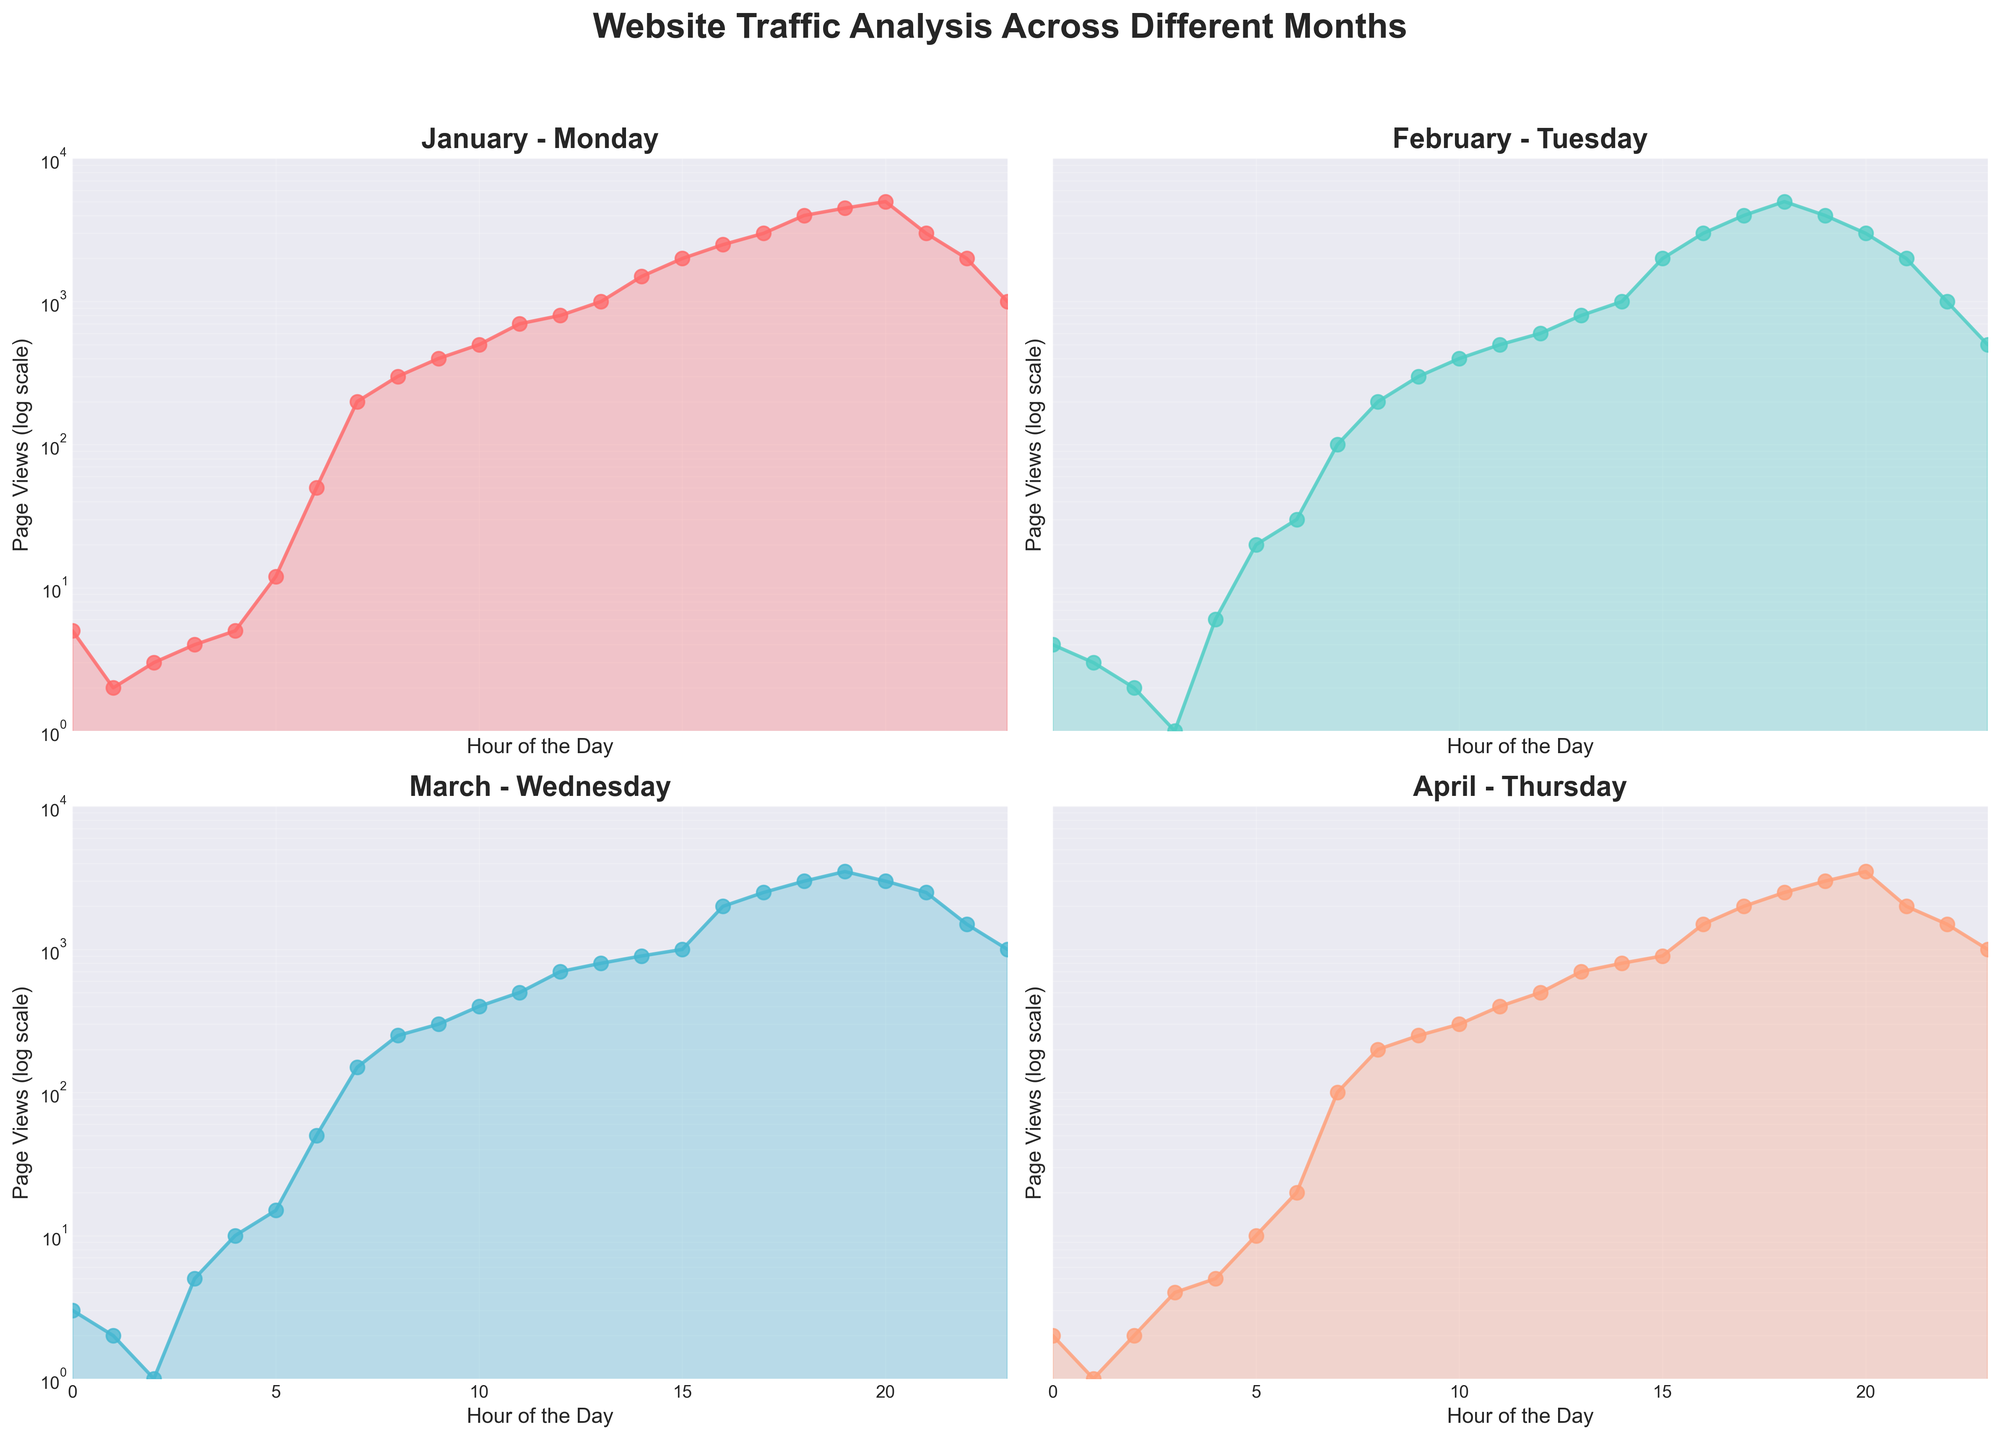How many subplots are in the figure? The figure contains a grid of subplots. Each subplot represents data for a different month. By looking at the layout, we can see a 2x2 grid, meaning there are 4 subplots in total.
Answer: 4 What does the y-axis represent? The y-axis is labeled "Page Views (log scale)," which indicates that it represents the number of page views in a logarithmic scale.
Answer: Page Views (log scale) Which month shows the highest peak hour page views? By observing the peaks on each subplot, we see the highest peak occurs in January, with the page views reaching 5000 at 20:00 hours.
Answer: January At what hour does February have the highest page views, and what is the value? In the February subplot, the highest page views occur at 18:00 hours with a value of 5000.
Answer: 18:00, 5000 What is the y-axis range? The y-axis is in log scale and ranges from 1 to 10000, as indicated by the tick marks on all subplots.
Answer: 1 to 10000 In which month does the website experience a drop in traffic after the peak? In February, traffic drops immediately after peaking at 5000 at 18:00 hours to 4000 at 19:00 hours.
Answer: February Compare the website traffic trends between March and April. What are the similarities? Both March and April show a gradual increase in page views starting early in the day, with peaks reaching around 3000–3500 in the evening hours.
Answer: Gradual increase, similar peaks How many hours in January have page views greater than or equal to 5000? Only one hour in January has page views of 5000, which is at 20:00 hours.
Answer: 1 Identify any hours where traffic drops to the lowest value in March, and state the corresponding value. In March, the lowest page views are observed at 2:00 hours with a value of 1.
Answer: 2:00, 1 Which month has the least variance in page views throughout the day? April shows the least variance as the increments in page views are smaller and more gradual compared to other months.
Answer: April 